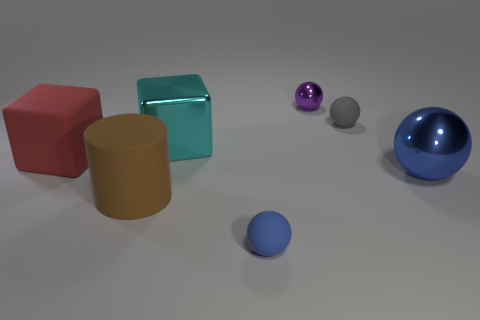Looking at the image, what time of day or lighting setup do you think is being represented? Based on the shadows and soft lighting in the image, it seems to represent an indoor setting with diffused artificial light, such as what might be found in a photography studio or a 3D rendering with a global illumination setup. Is there any indication of movement or stillness in the scene? The image suggests stillness; all objects cast crisp shadows directly beneath them, implying no movement and a stationary light source. This still life setup typically indicates a controlled environment where objects are arranged for the purpose of the composition. 